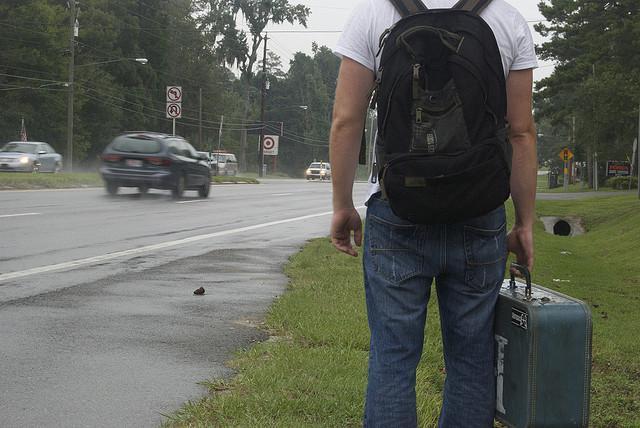How many red luggages are there?
Give a very brief answer. 0. How many cars do you see?
Give a very brief answer. 4. How many people are in the picture?
Give a very brief answer. 1. 